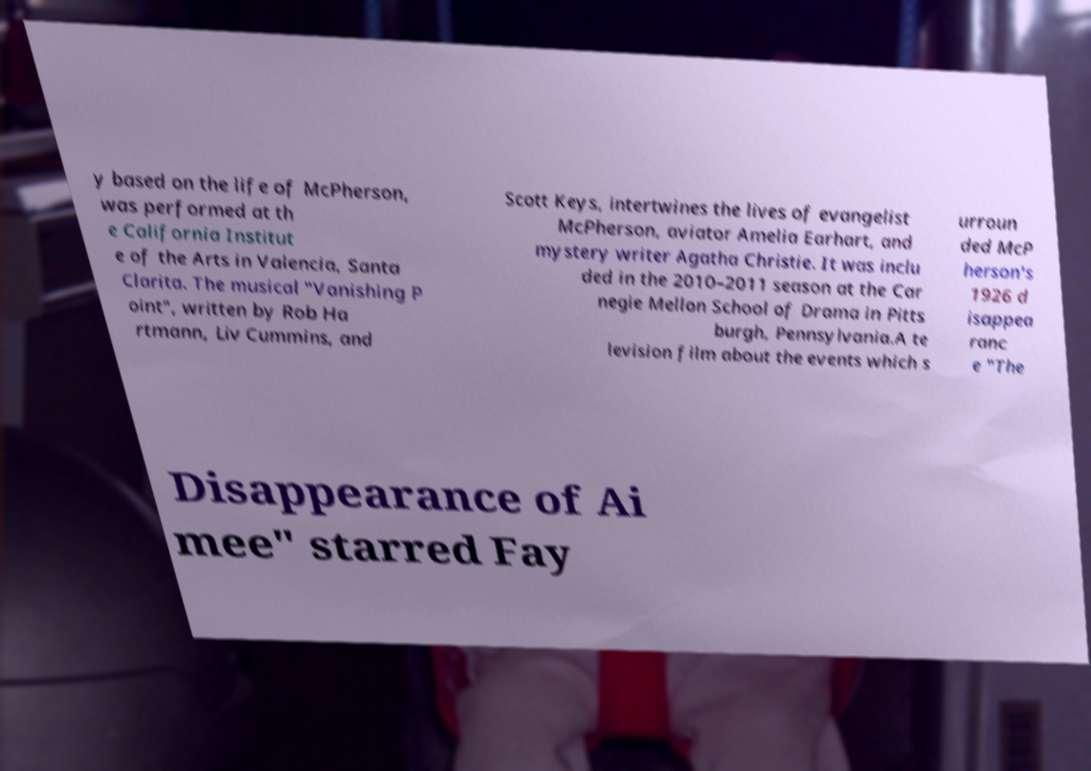Could you extract and type out the text from this image? y based on the life of McPherson, was performed at th e California Institut e of the Arts in Valencia, Santa Clarita. The musical "Vanishing P oint", written by Rob Ha rtmann, Liv Cummins, and Scott Keys, intertwines the lives of evangelist McPherson, aviator Amelia Earhart, and mystery writer Agatha Christie. It was inclu ded in the 2010–2011 season at the Car negie Mellon School of Drama in Pitts burgh, Pennsylvania.A te levision film about the events which s urroun ded McP herson's 1926 d isappea ranc e "The Disappearance of Ai mee" starred Fay 